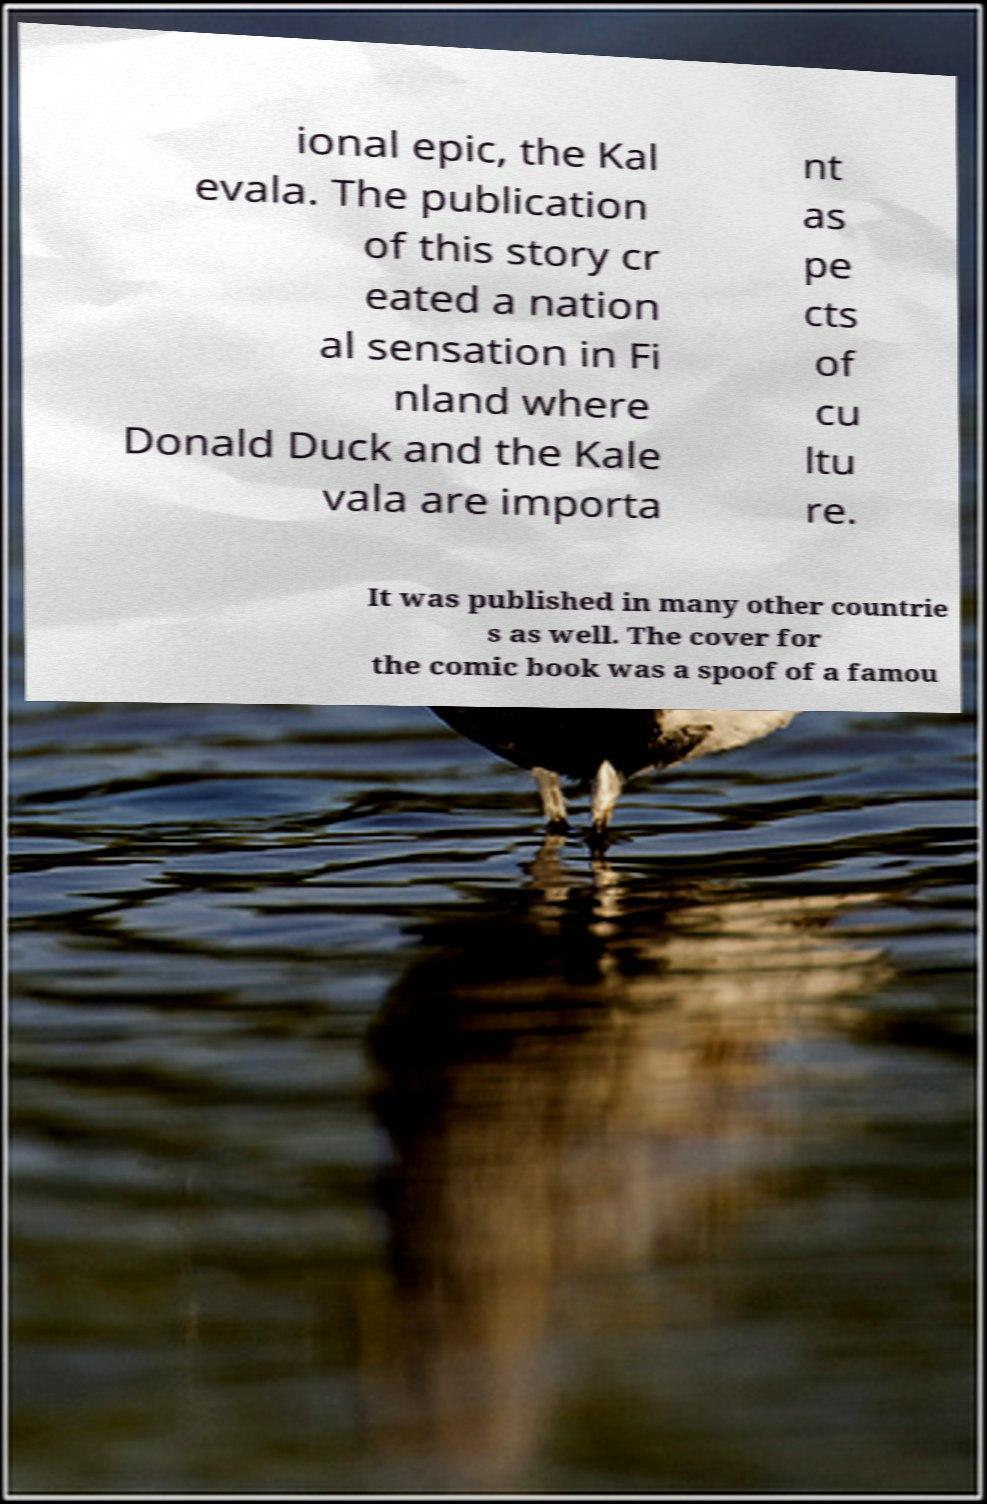Please identify and transcribe the text found in this image. ional epic, the Kal evala. The publication of this story cr eated a nation al sensation in Fi nland where Donald Duck and the Kale vala are importa nt as pe cts of cu ltu re. It was published in many other countrie s as well. The cover for the comic book was a spoof of a famou 